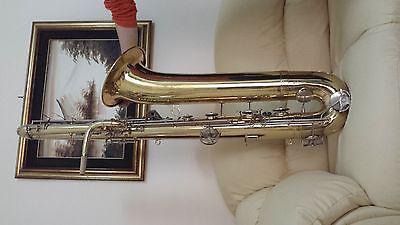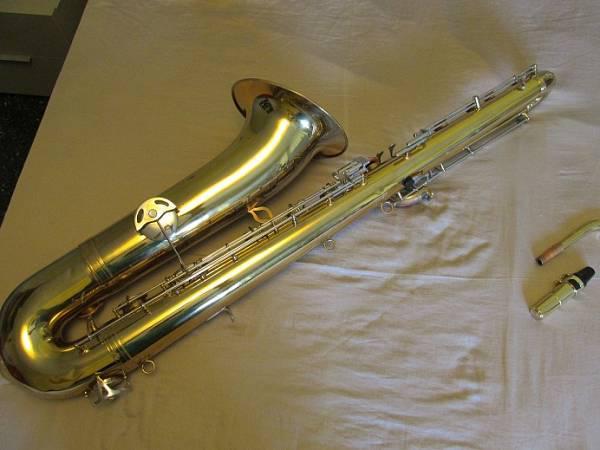The first image is the image on the left, the second image is the image on the right. Evaluate the accuracy of this statement regarding the images: "The right image shows a gold-colored saxophone displayed at an angle on off-white fabric, with its mouthpiece separated and laying near it.". Is it true? Answer yes or no. Yes. The first image is the image on the left, the second image is the image on the right. Examine the images to the left and right. Is the description "A saxophone with the mouth piece removed is laying on a wrinkled tan colored cloth." accurate? Answer yes or no. Yes. 